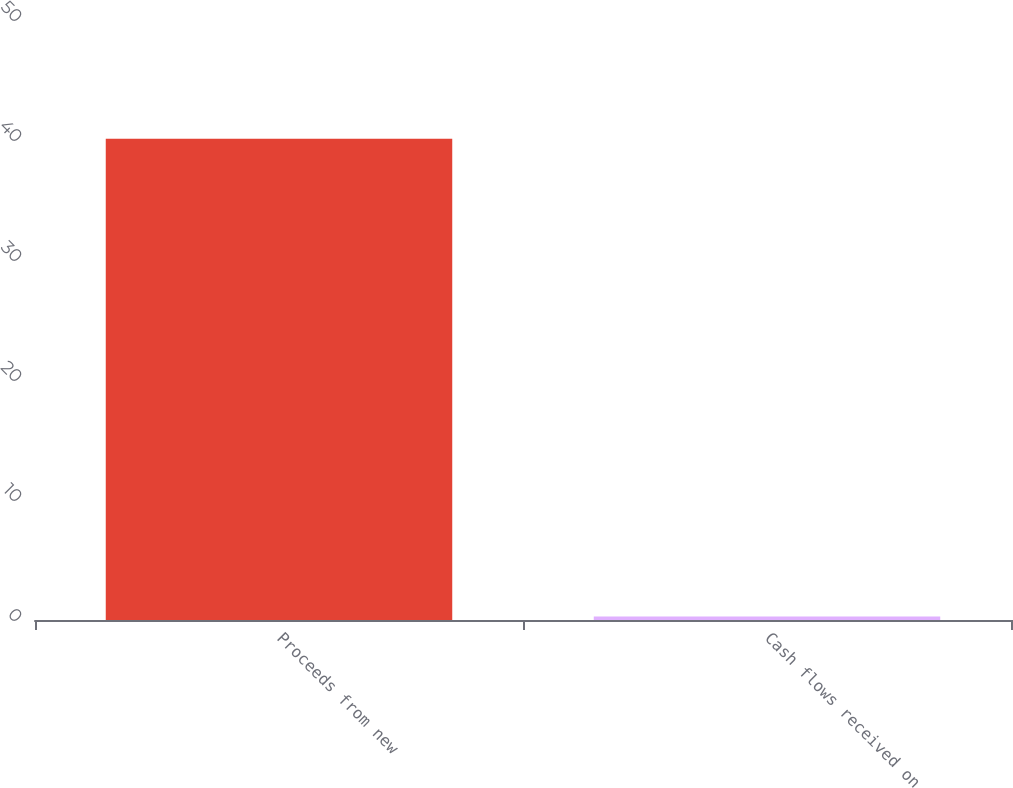Convert chart. <chart><loc_0><loc_0><loc_500><loc_500><bar_chart><fcel>Proceeds from new<fcel>Cash flows received on<nl><fcel>40.1<fcel>0.3<nl></chart> 